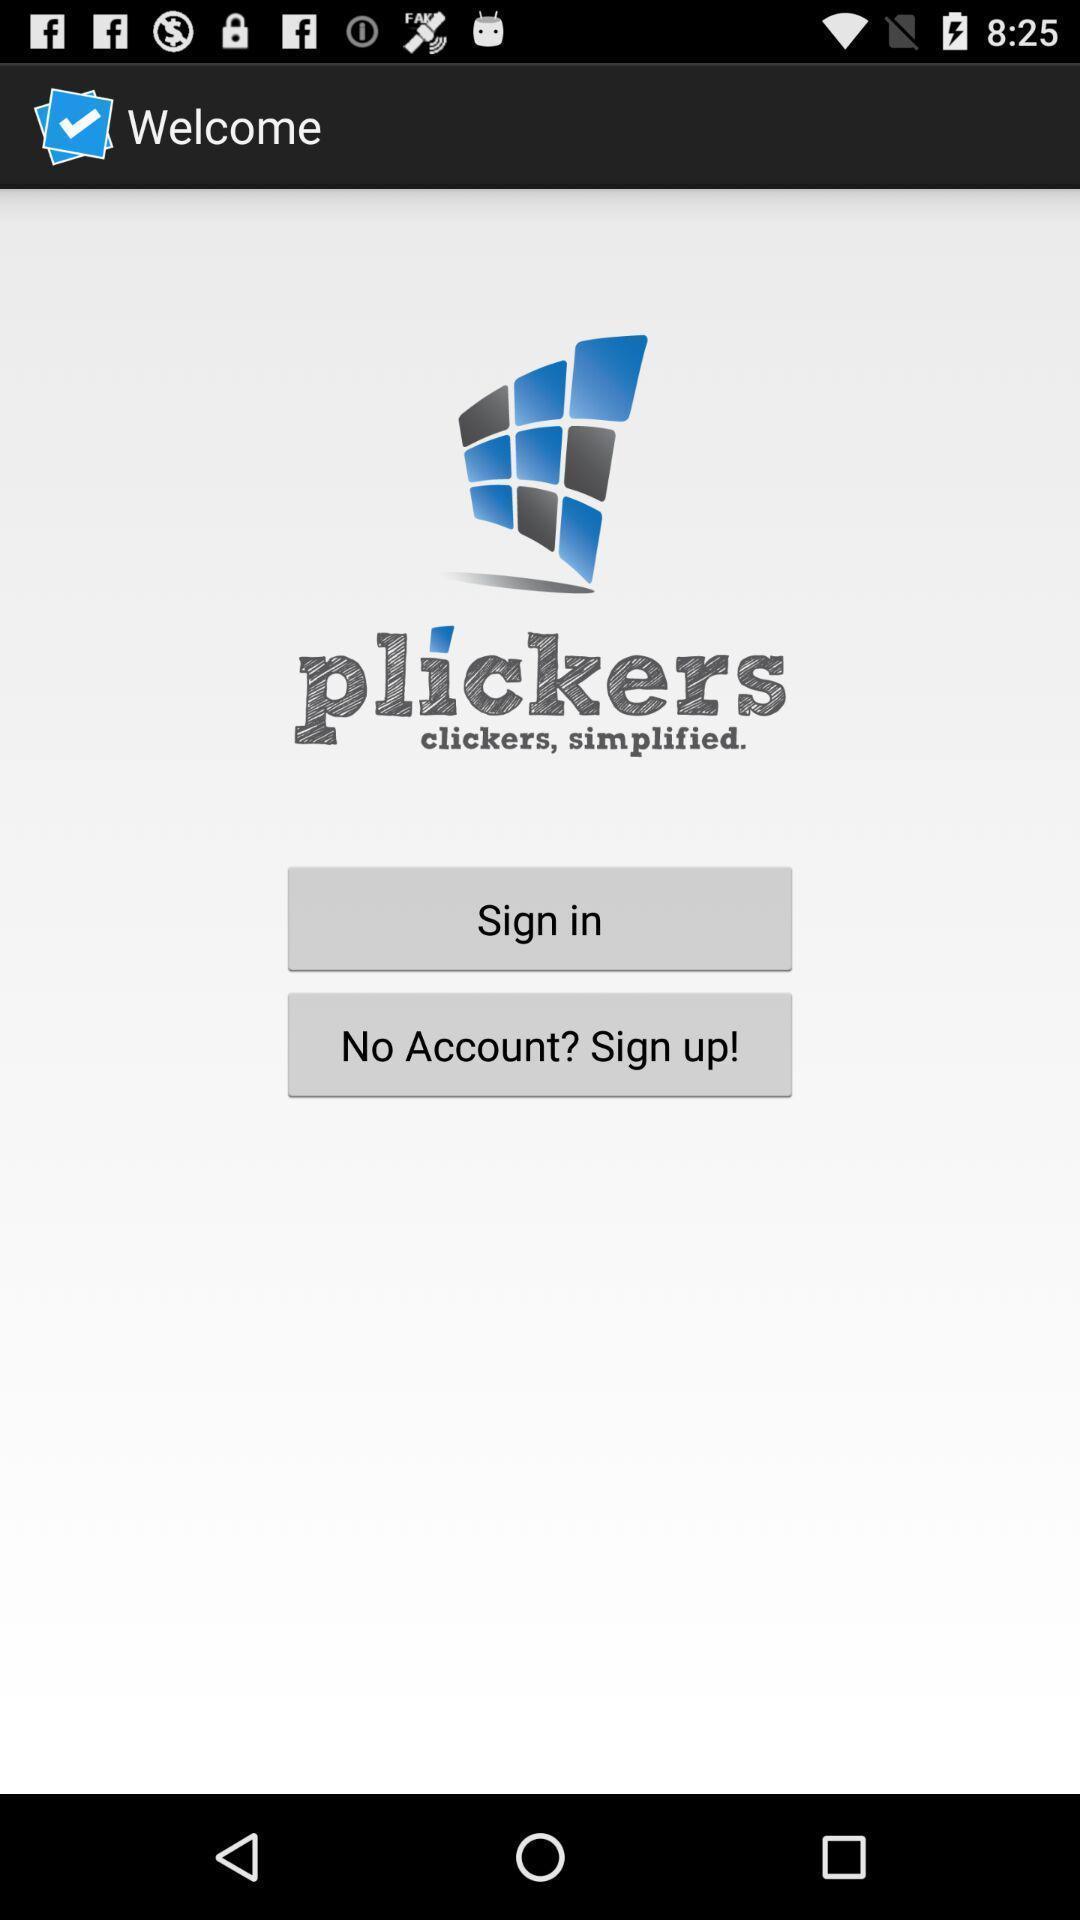Explain the elements present in this screenshot. Welcome page of the application with sign in option. 